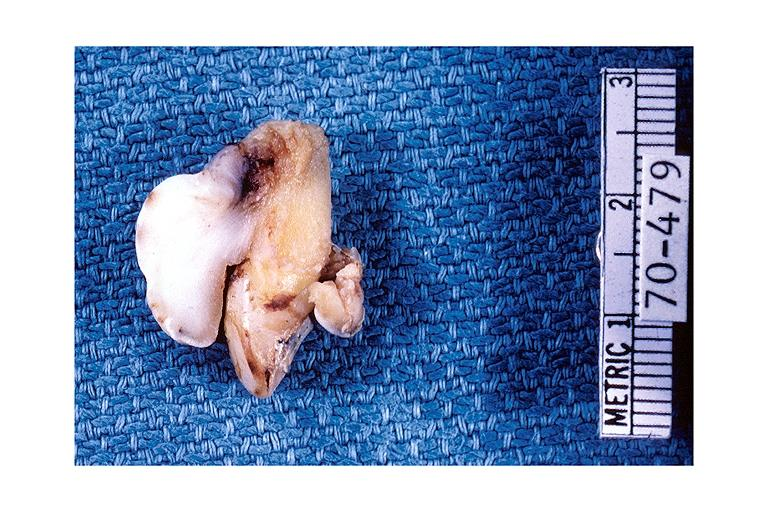where is this?
Answer the question using a single word or phrase. Oral 